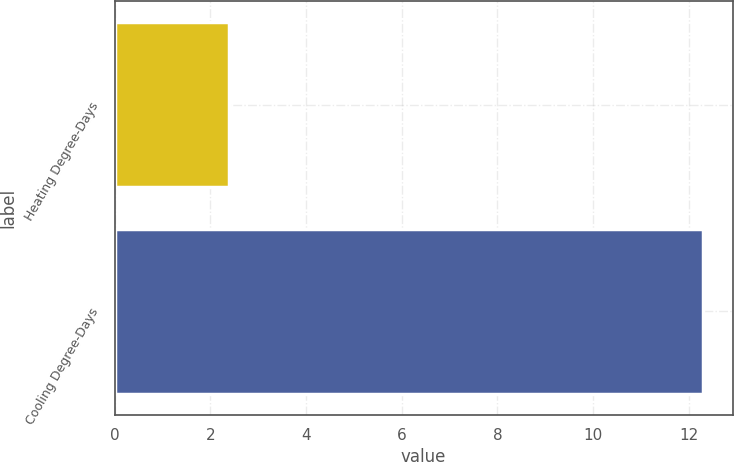Convert chart to OTSL. <chart><loc_0><loc_0><loc_500><loc_500><bar_chart><fcel>Heating Degree-Days<fcel>Cooling Degree-Days<nl><fcel>2.4<fcel>12.3<nl></chart> 